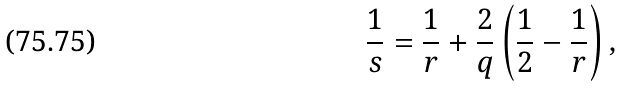Convert formula to latex. <formula><loc_0><loc_0><loc_500><loc_500>\frac { 1 } { s } = \frac { 1 } { r } + \frac { 2 } { q } \left ( \frac { 1 } { 2 } - \frac { 1 } { r } \right ) ,</formula> 